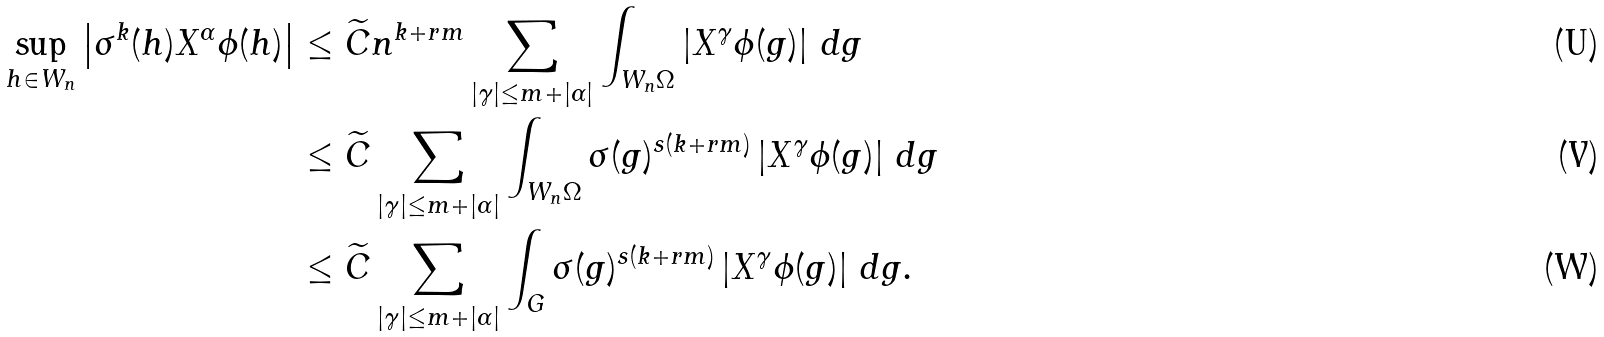<formula> <loc_0><loc_0><loc_500><loc_500>\sup _ { h \in W _ { n } } \left | \sigma ^ { k } ( h ) X ^ { \alpha } \phi ( h ) \right | & \leq \widetilde { C } n ^ { k + r m } \sum _ { | \gamma | \leq m + | \alpha | } \int _ { W _ { n } \Omega } \left | X ^ { \gamma } \phi ( g ) \right | \, d g \\ & \leq \widetilde { C } \sum _ { | \gamma | \leq m + | \alpha | } \int _ { W _ { n } \Omega } \sigma ( g ) ^ { s ( k + r m ) } \left | X ^ { \gamma } \phi ( g ) \right | \, d g \\ & \leq \widetilde { C } \sum _ { | \gamma | \leq m + | \alpha | } \int _ { G } \sigma ( g ) ^ { s ( k + r m ) } \left | X ^ { \gamma } \phi ( g ) \right | \, d g .</formula> 